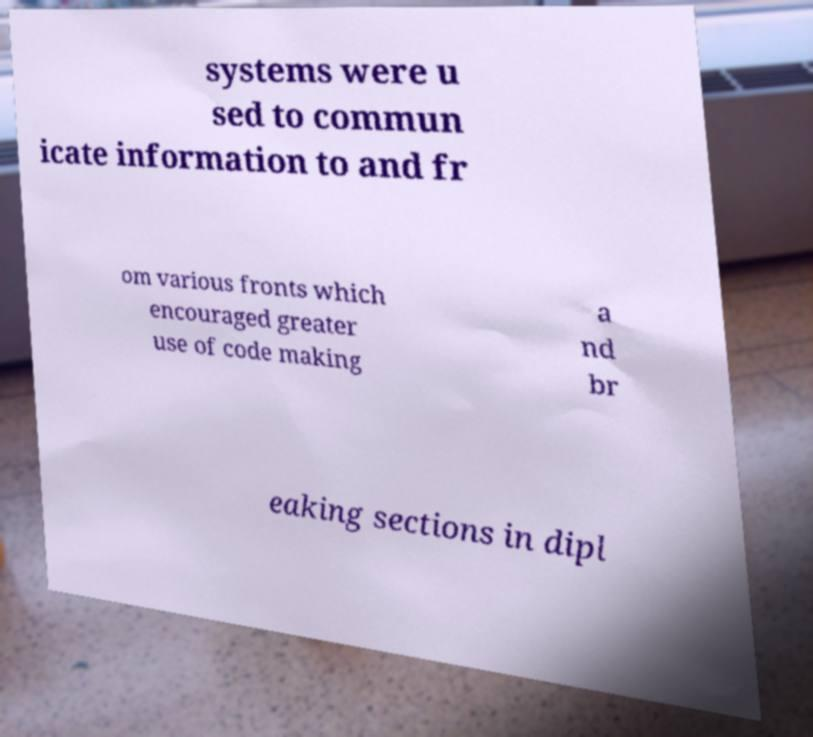Please identify and transcribe the text found in this image. systems were u sed to commun icate information to and fr om various fronts which encouraged greater use of code making a nd br eaking sections in dipl 